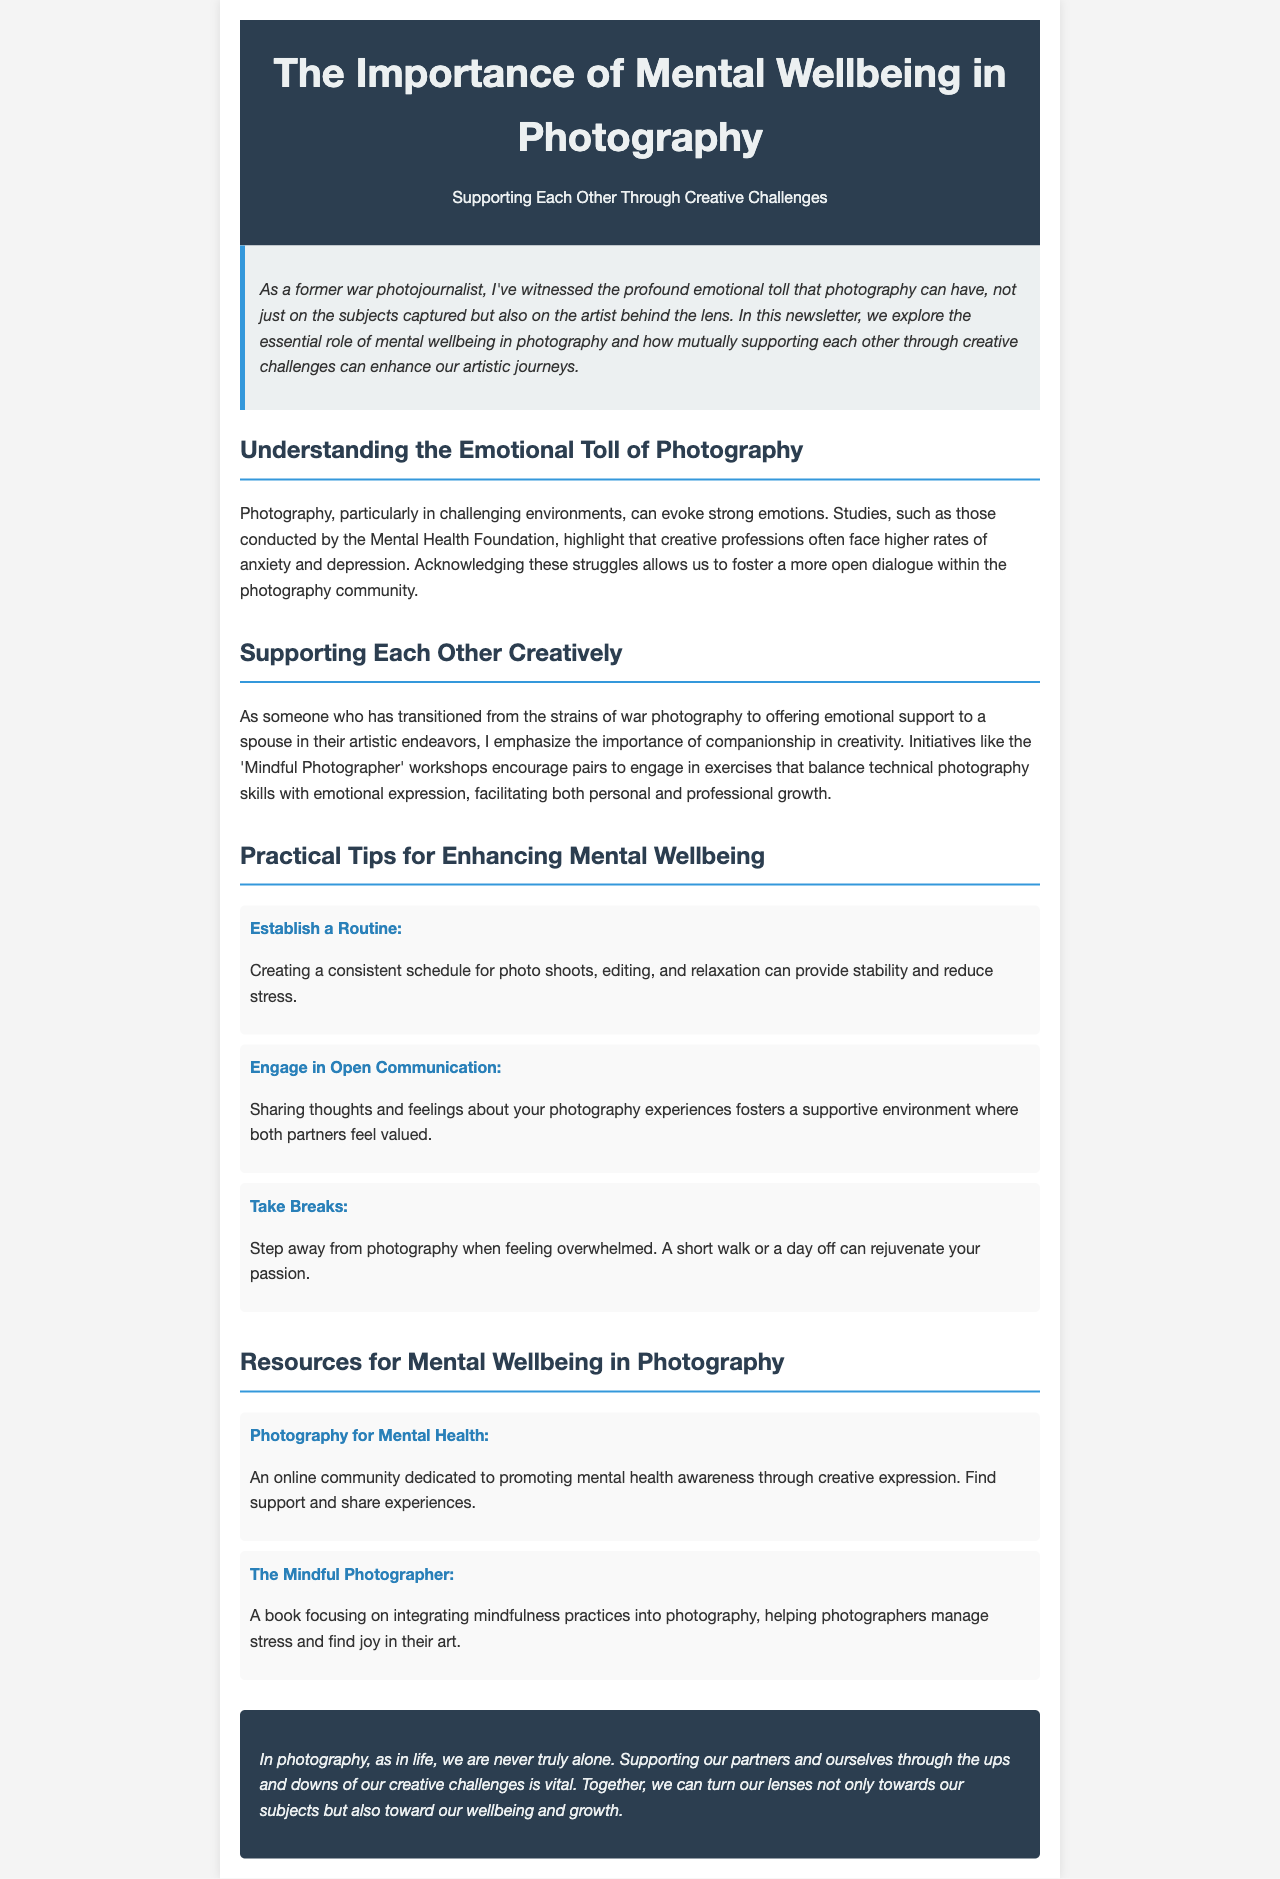What is the main theme of the newsletter? The newsletter focuses on the significance of mental wellbeing in photography and how to support each other through creative challenges.
Answer: Mental wellbeing in photography What is one of the organizations mentioned that focus on mental health in creative professions? The newsletter references studies conducted by this organization that highlight the emotional toll of creative professions.
Answer: Mental Health Foundation Name one practical tip for enhancing mental wellbeing mentioned in the document. One of the tips focuses on creating a stable environment that helps reduce stress through consistent activities.
Answer: Establish a Routine What is the title of the community dedicated to promoting mental health awareness through creative expression? The document describes a community dedicated to this cause.
Answer: Photography for Mental Health How does the newsletter suggest partners should communicate? The newsletter emphasizes the importance of this aspect for fostering a supportive environment.
Answer: Open Communication What type of workshops does the newsletter mention that can help photographers? These workshops encourage engaging in exercises that balance skills and emotional expression.
Answer: Mindful Photographer What is highlighted as vital in supporting partners through creative challenges? The document stresses the importance of this aspect in overcoming the difficulties associated with creativity.
Answer: Mutual support How many practical tips for enhancing mental wellbeing are provided in the newsletter? The document outlines this number of actionable suggestions to promote mental health.
Answer: Three 